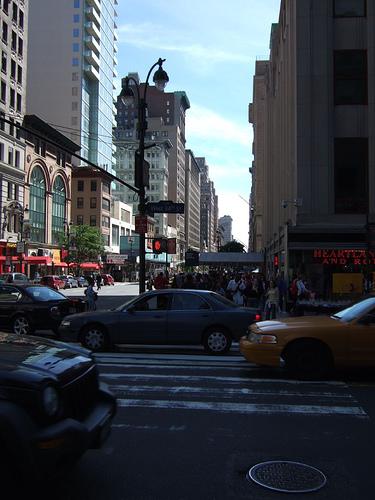Is this in the country?
Write a very short answer. No. What's the round circle in the road?
Write a very short answer. Manhole. Can a pedestrian cross now?
Quick response, please. No. 